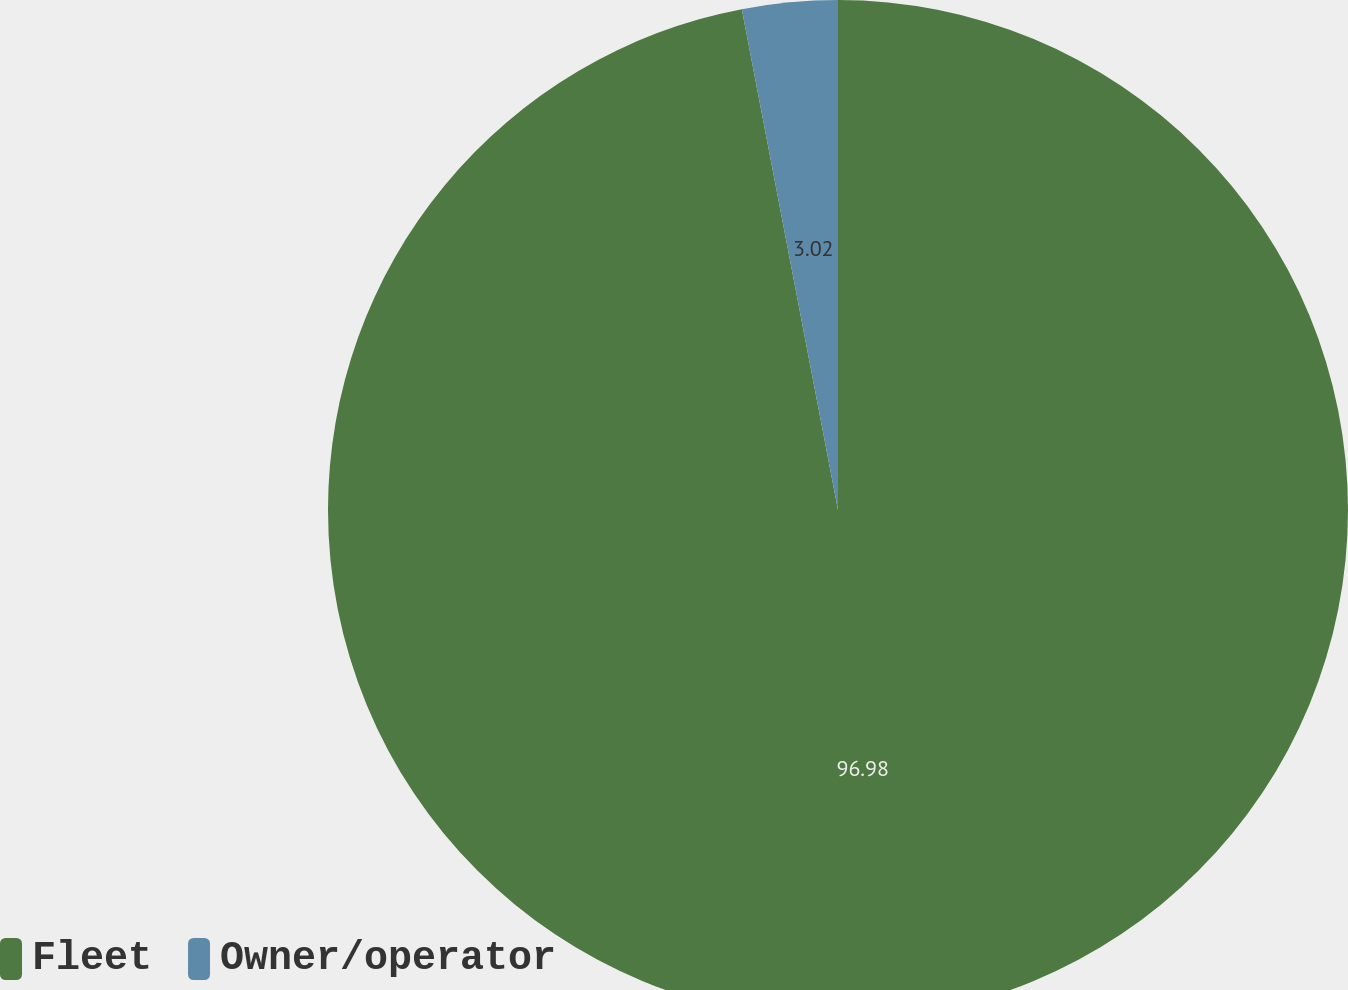Convert chart to OTSL. <chart><loc_0><loc_0><loc_500><loc_500><pie_chart><fcel>Fleet<fcel>Owner/operator<nl><fcel>96.98%<fcel>3.02%<nl></chart> 